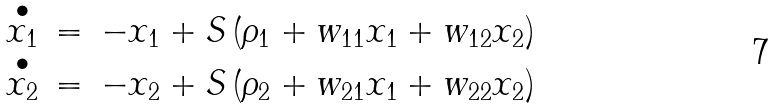Convert formula to latex. <formula><loc_0><loc_0><loc_500><loc_500>\begin{array} { l l l } \stackrel { \bullet } { x _ { 1 } } & = & - x _ { 1 } + S \left ( \rho _ { 1 } + w _ { 1 1 } x _ { 1 } + w _ { 1 2 } x _ { 2 } \right ) \\ \stackrel { \bullet } { x _ { 2 } } & = & - x _ { 2 } + S \left ( \rho _ { 2 } + w _ { 2 1 } x _ { 1 } + w _ { 2 2 } x _ { 2 } \right ) \end{array}</formula> 